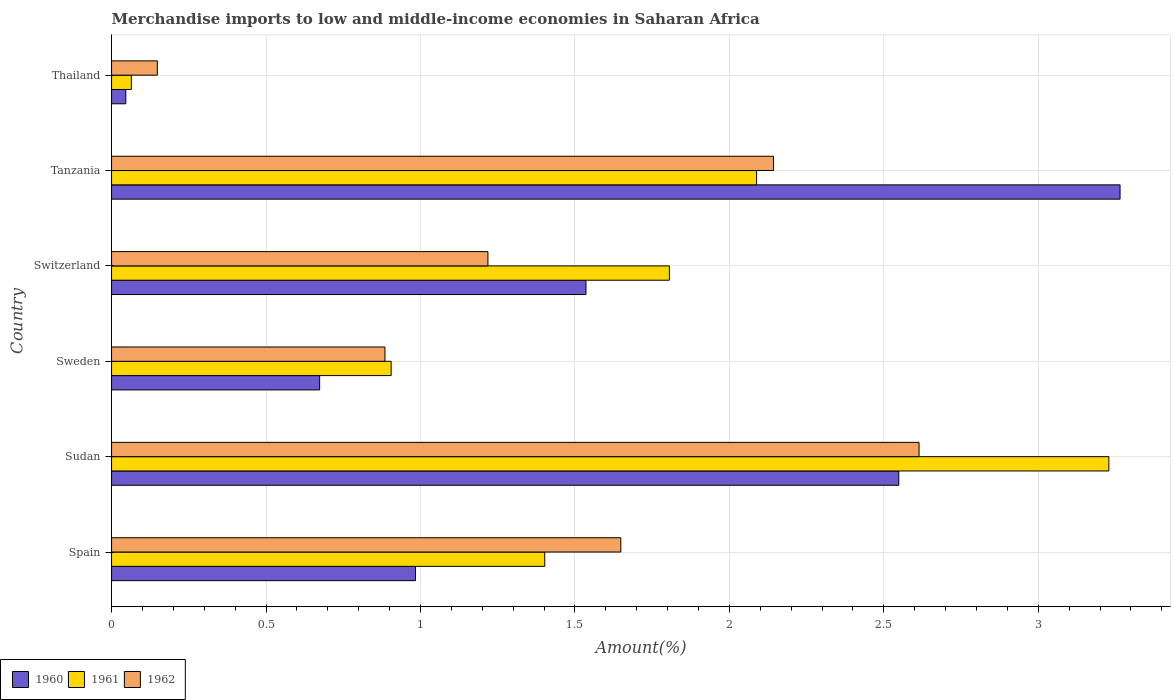How many different coloured bars are there?
Your answer should be compact. 3. How many groups of bars are there?
Your answer should be compact. 6. Are the number of bars per tick equal to the number of legend labels?
Your response must be concise. Yes. How many bars are there on the 1st tick from the top?
Provide a succinct answer. 3. How many bars are there on the 4th tick from the bottom?
Keep it short and to the point. 3. What is the label of the 1st group of bars from the top?
Give a very brief answer. Thailand. What is the percentage of amount earned from merchandise imports in 1960 in Spain?
Your response must be concise. 0.98. Across all countries, what is the maximum percentage of amount earned from merchandise imports in 1961?
Offer a terse response. 3.23. Across all countries, what is the minimum percentage of amount earned from merchandise imports in 1961?
Offer a terse response. 0.06. In which country was the percentage of amount earned from merchandise imports in 1962 maximum?
Provide a succinct answer. Sudan. In which country was the percentage of amount earned from merchandise imports in 1960 minimum?
Ensure brevity in your answer.  Thailand. What is the total percentage of amount earned from merchandise imports in 1961 in the graph?
Provide a succinct answer. 9.49. What is the difference between the percentage of amount earned from merchandise imports in 1960 in Sudan and that in Switzerland?
Your answer should be very brief. 1.01. What is the difference between the percentage of amount earned from merchandise imports in 1962 in Thailand and the percentage of amount earned from merchandise imports in 1960 in Sweden?
Offer a very short reply. -0.53. What is the average percentage of amount earned from merchandise imports in 1961 per country?
Your response must be concise. 1.58. What is the difference between the percentage of amount earned from merchandise imports in 1961 and percentage of amount earned from merchandise imports in 1962 in Tanzania?
Keep it short and to the point. -0.05. What is the ratio of the percentage of amount earned from merchandise imports in 1961 in Spain to that in Sudan?
Offer a terse response. 0.43. Is the percentage of amount earned from merchandise imports in 1960 in Sweden less than that in Thailand?
Make the answer very short. No. Is the difference between the percentage of amount earned from merchandise imports in 1961 in Sudan and Thailand greater than the difference between the percentage of amount earned from merchandise imports in 1962 in Sudan and Thailand?
Your response must be concise. Yes. What is the difference between the highest and the second highest percentage of amount earned from merchandise imports in 1961?
Keep it short and to the point. 1.14. What is the difference between the highest and the lowest percentage of amount earned from merchandise imports in 1962?
Give a very brief answer. 2.47. In how many countries, is the percentage of amount earned from merchandise imports in 1961 greater than the average percentage of amount earned from merchandise imports in 1961 taken over all countries?
Your answer should be very brief. 3. What does the 2nd bar from the top in Sweden represents?
Ensure brevity in your answer.  1961. What does the 3rd bar from the bottom in Spain represents?
Your response must be concise. 1962. Is it the case that in every country, the sum of the percentage of amount earned from merchandise imports in 1961 and percentage of amount earned from merchandise imports in 1960 is greater than the percentage of amount earned from merchandise imports in 1962?
Your response must be concise. No. Are the values on the major ticks of X-axis written in scientific E-notation?
Offer a very short reply. No. Does the graph contain any zero values?
Offer a very short reply. No. What is the title of the graph?
Your response must be concise. Merchandise imports to low and middle-income economies in Saharan Africa. Does "1973" appear as one of the legend labels in the graph?
Offer a very short reply. No. What is the label or title of the X-axis?
Provide a short and direct response. Amount(%). What is the label or title of the Y-axis?
Make the answer very short. Country. What is the Amount(%) of 1960 in Spain?
Your response must be concise. 0.98. What is the Amount(%) in 1961 in Spain?
Your answer should be compact. 1.4. What is the Amount(%) in 1962 in Spain?
Provide a succinct answer. 1.65. What is the Amount(%) of 1960 in Sudan?
Offer a terse response. 2.55. What is the Amount(%) in 1961 in Sudan?
Your answer should be compact. 3.23. What is the Amount(%) in 1962 in Sudan?
Your answer should be compact. 2.61. What is the Amount(%) of 1960 in Sweden?
Keep it short and to the point. 0.67. What is the Amount(%) in 1961 in Sweden?
Ensure brevity in your answer.  0.91. What is the Amount(%) of 1962 in Sweden?
Offer a terse response. 0.89. What is the Amount(%) of 1960 in Switzerland?
Make the answer very short. 1.54. What is the Amount(%) in 1961 in Switzerland?
Offer a terse response. 1.81. What is the Amount(%) of 1962 in Switzerland?
Offer a very short reply. 1.22. What is the Amount(%) in 1960 in Tanzania?
Keep it short and to the point. 3.26. What is the Amount(%) of 1961 in Tanzania?
Make the answer very short. 2.09. What is the Amount(%) in 1962 in Tanzania?
Offer a very short reply. 2.14. What is the Amount(%) of 1960 in Thailand?
Your answer should be very brief. 0.05. What is the Amount(%) in 1961 in Thailand?
Offer a terse response. 0.06. What is the Amount(%) in 1962 in Thailand?
Provide a short and direct response. 0.15. Across all countries, what is the maximum Amount(%) in 1960?
Offer a very short reply. 3.26. Across all countries, what is the maximum Amount(%) of 1961?
Give a very brief answer. 3.23. Across all countries, what is the maximum Amount(%) in 1962?
Give a very brief answer. 2.61. Across all countries, what is the minimum Amount(%) of 1960?
Your response must be concise. 0.05. Across all countries, what is the minimum Amount(%) of 1961?
Keep it short and to the point. 0.06. Across all countries, what is the minimum Amount(%) in 1962?
Give a very brief answer. 0.15. What is the total Amount(%) of 1960 in the graph?
Offer a terse response. 9.05. What is the total Amount(%) in 1961 in the graph?
Provide a short and direct response. 9.49. What is the total Amount(%) of 1962 in the graph?
Keep it short and to the point. 8.66. What is the difference between the Amount(%) in 1960 in Spain and that in Sudan?
Give a very brief answer. -1.56. What is the difference between the Amount(%) in 1961 in Spain and that in Sudan?
Give a very brief answer. -1.83. What is the difference between the Amount(%) of 1962 in Spain and that in Sudan?
Provide a succinct answer. -0.97. What is the difference between the Amount(%) in 1960 in Spain and that in Sweden?
Give a very brief answer. 0.31. What is the difference between the Amount(%) of 1961 in Spain and that in Sweden?
Make the answer very short. 0.5. What is the difference between the Amount(%) of 1962 in Spain and that in Sweden?
Your answer should be compact. 0.76. What is the difference between the Amount(%) of 1960 in Spain and that in Switzerland?
Your response must be concise. -0.55. What is the difference between the Amount(%) in 1961 in Spain and that in Switzerland?
Your answer should be very brief. -0.4. What is the difference between the Amount(%) of 1962 in Spain and that in Switzerland?
Provide a short and direct response. 0.43. What is the difference between the Amount(%) in 1960 in Spain and that in Tanzania?
Offer a terse response. -2.28. What is the difference between the Amount(%) of 1961 in Spain and that in Tanzania?
Ensure brevity in your answer.  -0.69. What is the difference between the Amount(%) in 1962 in Spain and that in Tanzania?
Your response must be concise. -0.49. What is the difference between the Amount(%) of 1960 in Spain and that in Thailand?
Make the answer very short. 0.94. What is the difference between the Amount(%) of 1961 in Spain and that in Thailand?
Make the answer very short. 1.34. What is the difference between the Amount(%) in 1962 in Spain and that in Thailand?
Make the answer very short. 1.5. What is the difference between the Amount(%) of 1960 in Sudan and that in Sweden?
Your response must be concise. 1.87. What is the difference between the Amount(%) in 1961 in Sudan and that in Sweden?
Offer a terse response. 2.32. What is the difference between the Amount(%) in 1962 in Sudan and that in Sweden?
Ensure brevity in your answer.  1.73. What is the difference between the Amount(%) of 1960 in Sudan and that in Switzerland?
Your answer should be compact. 1.01. What is the difference between the Amount(%) of 1961 in Sudan and that in Switzerland?
Ensure brevity in your answer.  1.42. What is the difference between the Amount(%) of 1962 in Sudan and that in Switzerland?
Provide a succinct answer. 1.4. What is the difference between the Amount(%) of 1960 in Sudan and that in Tanzania?
Make the answer very short. -0.72. What is the difference between the Amount(%) of 1961 in Sudan and that in Tanzania?
Offer a terse response. 1.14. What is the difference between the Amount(%) of 1962 in Sudan and that in Tanzania?
Your answer should be very brief. 0.47. What is the difference between the Amount(%) in 1960 in Sudan and that in Thailand?
Make the answer very short. 2.5. What is the difference between the Amount(%) in 1961 in Sudan and that in Thailand?
Keep it short and to the point. 3.16. What is the difference between the Amount(%) of 1962 in Sudan and that in Thailand?
Give a very brief answer. 2.47. What is the difference between the Amount(%) of 1960 in Sweden and that in Switzerland?
Offer a very short reply. -0.86. What is the difference between the Amount(%) in 1961 in Sweden and that in Switzerland?
Give a very brief answer. -0.9. What is the difference between the Amount(%) in 1962 in Sweden and that in Switzerland?
Provide a succinct answer. -0.33. What is the difference between the Amount(%) of 1960 in Sweden and that in Tanzania?
Make the answer very short. -2.59. What is the difference between the Amount(%) of 1961 in Sweden and that in Tanzania?
Offer a terse response. -1.18. What is the difference between the Amount(%) in 1962 in Sweden and that in Tanzania?
Keep it short and to the point. -1.26. What is the difference between the Amount(%) in 1960 in Sweden and that in Thailand?
Your answer should be very brief. 0.63. What is the difference between the Amount(%) in 1961 in Sweden and that in Thailand?
Offer a terse response. 0.84. What is the difference between the Amount(%) in 1962 in Sweden and that in Thailand?
Offer a very short reply. 0.74. What is the difference between the Amount(%) in 1960 in Switzerland and that in Tanzania?
Provide a short and direct response. -1.73. What is the difference between the Amount(%) in 1961 in Switzerland and that in Tanzania?
Your answer should be compact. -0.28. What is the difference between the Amount(%) in 1962 in Switzerland and that in Tanzania?
Make the answer very short. -0.92. What is the difference between the Amount(%) in 1960 in Switzerland and that in Thailand?
Give a very brief answer. 1.49. What is the difference between the Amount(%) of 1961 in Switzerland and that in Thailand?
Your answer should be very brief. 1.74. What is the difference between the Amount(%) of 1962 in Switzerland and that in Thailand?
Give a very brief answer. 1.07. What is the difference between the Amount(%) of 1960 in Tanzania and that in Thailand?
Ensure brevity in your answer.  3.22. What is the difference between the Amount(%) of 1961 in Tanzania and that in Thailand?
Make the answer very short. 2.02. What is the difference between the Amount(%) in 1962 in Tanzania and that in Thailand?
Provide a succinct answer. 1.99. What is the difference between the Amount(%) in 1960 in Spain and the Amount(%) in 1961 in Sudan?
Offer a very short reply. -2.24. What is the difference between the Amount(%) in 1960 in Spain and the Amount(%) in 1962 in Sudan?
Offer a terse response. -1.63. What is the difference between the Amount(%) in 1961 in Spain and the Amount(%) in 1962 in Sudan?
Your response must be concise. -1.21. What is the difference between the Amount(%) of 1960 in Spain and the Amount(%) of 1961 in Sweden?
Provide a succinct answer. 0.08. What is the difference between the Amount(%) in 1960 in Spain and the Amount(%) in 1962 in Sweden?
Your answer should be compact. 0.1. What is the difference between the Amount(%) in 1961 in Spain and the Amount(%) in 1962 in Sweden?
Offer a very short reply. 0.52. What is the difference between the Amount(%) in 1960 in Spain and the Amount(%) in 1961 in Switzerland?
Keep it short and to the point. -0.82. What is the difference between the Amount(%) in 1960 in Spain and the Amount(%) in 1962 in Switzerland?
Make the answer very short. -0.23. What is the difference between the Amount(%) of 1961 in Spain and the Amount(%) of 1962 in Switzerland?
Provide a short and direct response. 0.18. What is the difference between the Amount(%) in 1960 in Spain and the Amount(%) in 1961 in Tanzania?
Provide a succinct answer. -1.1. What is the difference between the Amount(%) in 1960 in Spain and the Amount(%) in 1962 in Tanzania?
Your response must be concise. -1.16. What is the difference between the Amount(%) of 1961 in Spain and the Amount(%) of 1962 in Tanzania?
Give a very brief answer. -0.74. What is the difference between the Amount(%) of 1960 in Spain and the Amount(%) of 1961 in Thailand?
Make the answer very short. 0.92. What is the difference between the Amount(%) in 1960 in Spain and the Amount(%) in 1962 in Thailand?
Your answer should be compact. 0.84. What is the difference between the Amount(%) in 1961 in Spain and the Amount(%) in 1962 in Thailand?
Ensure brevity in your answer.  1.25. What is the difference between the Amount(%) in 1960 in Sudan and the Amount(%) in 1961 in Sweden?
Keep it short and to the point. 1.64. What is the difference between the Amount(%) of 1960 in Sudan and the Amount(%) of 1962 in Sweden?
Offer a terse response. 1.66. What is the difference between the Amount(%) of 1961 in Sudan and the Amount(%) of 1962 in Sweden?
Your answer should be very brief. 2.34. What is the difference between the Amount(%) in 1960 in Sudan and the Amount(%) in 1961 in Switzerland?
Give a very brief answer. 0.74. What is the difference between the Amount(%) in 1960 in Sudan and the Amount(%) in 1962 in Switzerland?
Provide a short and direct response. 1.33. What is the difference between the Amount(%) of 1961 in Sudan and the Amount(%) of 1962 in Switzerland?
Your answer should be very brief. 2.01. What is the difference between the Amount(%) in 1960 in Sudan and the Amount(%) in 1961 in Tanzania?
Your response must be concise. 0.46. What is the difference between the Amount(%) in 1960 in Sudan and the Amount(%) in 1962 in Tanzania?
Ensure brevity in your answer.  0.41. What is the difference between the Amount(%) of 1961 in Sudan and the Amount(%) of 1962 in Tanzania?
Your response must be concise. 1.09. What is the difference between the Amount(%) of 1960 in Sudan and the Amount(%) of 1961 in Thailand?
Your answer should be compact. 2.48. What is the difference between the Amount(%) of 1960 in Sudan and the Amount(%) of 1962 in Thailand?
Offer a terse response. 2.4. What is the difference between the Amount(%) in 1961 in Sudan and the Amount(%) in 1962 in Thailand?
Ensure brevity in your answer.  3.08. What is the difference between the Amount(%) in 1960 in Sweden and the Amount(%) in 1961 in Switzerland?
Ensure brevity in your answer.  -1.13. What is the difference between the Amount(%) in 1960 in Sweden and the Amount(%) in 1962 in Switzerland?
Make the answer very short. -0.54. What is the difference between the Amount(%) in 1961 in Sweden and the Amount(%) in 1962 in Switzerland?
Make the answer very short. -0.31. What is the difference between the Amount(%) of 1960 in Sweden and the Amount(%) of 1961 in Tanzania?
Your answer should be compact. -1.41. What is the difference between the Amount(%) of 1960 in Sweden and the Amount(%) of 1962 in Tanzania?
Make the answer very short. -1.47. What is the difference between the Amount(%) in 1961 in Sweden and the Amount(%) in 1962 in Tanzania?
Provide a short and direct response. -1.24. What is the difference between the Amount(%) of 1960 in Sweden and the Amount(%) of 1961 in Thailand?
Offer a terse response. 0.61. What is the difference between the Amount(%) in 1960 in Sweden and the Amount(%) in 1962 in Thailand?
Provide a succinct answer. 0.53. What is the difference between the Amount(%) in 1961 in Sweden and the Amount(%) in 1962 in Thailand?
Ensure brevity in your answer.  0.76. What is the difference between the Amount(%) in 1960 in Switzerland and the Amount(%) in 1961 in Tanzania?
Your response must be concise. -0.55. What is the difference between the Amount(%) of 1960 in Switzerland and the Amount(%) of 1962 in Tanzania?
Your answer should be compact. -0.61. What is the difference between the Amount(%) in 1961 in Switzerland and the Amount(%) in 1962 in Tanzania?
Provide a succinct answer. -0.34. What is the difference between the Amount(%) of 1960 in Switzerland and the Amount(%) of 1961 in Thailand?
Ensure brevity in your answer.  1.47. What is the difference between the Amount(%) of 1960 in Switzerland and the Amount(%) of 1962 in Thailand?
Offer a terse response. 1.39. What is the difference between the Amount(%) of 1961 in Switzerland and the Amount(%) of 1962 in Thailand?
Offer a very short reply. 1.66. What is the difference between the Amount(%) of 1960 in Tanzania and the Amount(%) of 1961 in Thailand?
Provide a succinct answer. 3.2. What is the difference between the Amount(%) of 1960 in Tanzania and the Amount(%) of 1962 in Thailand?
Your answer should be very brief. 3.12. What is the difference between the Amount(%) of 1961 in Tanzania and the Amount(%) of 1962 in Thailand?
Offer a very short reply. 1.94. What is the average Amount(%) of 1960 per country?
Your answer should be compact. 1.51. What is the average Amount(%) of 1961 per country?
Keep it short and to the point. 1.58. What is the average Amount(%) of 1962 per country?
Your response must be concise. 1.44. What is the difference between the Amount(%) of 1960 and Amount(%) of 1961 in Spain?
Offer a very short reply. -0.42. What is the difference between the Amount(%) in 1960 and Amount(%) in 1962 in Spain?
Your answer should be compact. -0.66. What is the difference between the Amount(%) of 1961 and Amount(%) of 1962 in Spain?
Your answer should be compact. -0.25. What is the difference between the Amount(%) in 1960 and Amount(%) in 1961 in Sudan?
Provide a succinct answer. -0.68. What is the difference between the Amount(%) in 1960 and Amount(%) in 1962 in Sudan?
Provide a short and direct response. -0.07. What is the difference between the Amount(%) in 1961 and Amount(%) in 1962 in Sudan?
Your answer should be very brief. 0.61. What is the difference between the Amount(%) of 1960 and Amount(%) of 1961 in Sweden?
Provide a succinct answer. -0.23. What is the difference between the Amount(%) of 1960 and Amount(%) of 1962 in Sweden?
Give a very brief answer. -0.21. What is the difference between the Amount(%) in 1960 and Amount(%) in 1961 in Switzerland?
Ensure brevity in your answer.  -0.27. What is the difference between the Amount(%) of 1960 and Amount(%) of 1962 in Switzerland?
Offer a terse response. 0.32. What is the difference between the Amount(%) of 1961 and Amount(%) of 1962 in Switzerland?
Offer a very short reply. 0.59. What is the difference between the Amount(%) of 1960 and Amount(%) of 1961 in Tanzania?
Offer a terse response. 1.18. What is the difference between the Amount(%) in 1960 and Amount(%) in 1962 in Tanzania?
Your response must be concise. 1.12. What is the difference between the Amount(%) of 1961 and Amount(%) of 1962 in Tanzania?
Your answer should be compact. -0.05. What is the difference between the Amount(%) of 1960 and Amount(%) of 1961 in Thailand?
Your response must be concise. -0.02. What is the difference between the Amount(%) in 1960 and Amount(%) in 1962 in Thailand?
Keep it short and to the point. -0.1. What is the difference between the Amount(%) in 1961 and Amount(%) in 1962 in Thailand?
Make the answer very short. -0.08. What is the ratio of the Amount(%) in 1960 in Spain to that in Sudan?
Offer a terse response. 0.39. What is the ratio of the Amount(%) in 1961 in Spain to that in Sudan?
Ensure brevity in your answer.  0.43. What is the ratio of the Amount(%) of 1962 in Spain to that in Sudan?
Offer a very short reply. 0.63. What is the ratio of the Amount(%) of 1960 in Spain to that in Sweden?
Provide a succinct answer. 1.46. What is the ratio of the Amount(%) in 1961 in Spain to that in Sweden?
Your answer should be compact. 1.55. What is the ratio of the Amount(%) in 1962 in Spain to that in Sweden?
Offer a very short reply. 1.86. What is the ratio of the Amount(%) of 1960 in Spain to that in Switzerland?
Offer a very short reply. 0.64. What is the ratio of the Amount(%) of 1961 in Spain to that in Switzerland?
Offer a terse response. 0.78. What is the ratio of the Amount(%) in 1962 in Spain to that in Switzerland?
Your answer should be very brief. 1.35. What is the ratio of the Amount(%) of 1960 in Spain to that in Tanzania?
Provide a short and direct response. 0.3. What is the ratio of the Amount(%) of 1961 in Spain to that in Tanzania?
Provide a succinct answer. 0.67. What is the ratio of the Amount(%) of 1962 in Spain to that in Tanzania?
Keep it short and to the point. 0.77. What is the ratio of the Amount(%) of 1960 in Spain to that in Thailand?
Your response must be concise. 21.35. What is the ratio of the Amount(%) in 1961 in Spain to that in Thailand?
Offer a terse response. 21.89. What is the ratio of the Amount(%) in 1962 in Spain to that in Thailand?
Offer a terse response. 11.13. What is the ratio of the Amount(%) in 1960 in Sudan to that in Sweden?
Offer a terse response. 3.78. What is the ratio of the Amount(%) in 1961 in Sudan to that in Sweden?
Provide a short and direct response. 3.57. What is the ratio of the Amount(%) of 1962 in Sudan to that in Sweden?
Give a very brief answer. 2.95. What is the ratio of the Amount(%) of 1960 in Sudan to that in Switzerland?
Ensure brevity in your answer.  1.66. What is the ratio of the Amount(%) of 1961 in Sudan to that in Switzerland?
Your answer should be compact. 1.79. What is the ratio of the Amount(%) of 1962 in Sudan to that in Switzerland?
Offer a terse response. 2.15. What is the ratio of the Amount(%) in 1960 in Sudan to that in Tanzania?
Give a very brief answer. 0.78. What is the ratio of the Amount(%) of 1961 in Sudan to that in Tanzania?
Keep it short and to the point. 1.55. What is the ratio of the Amount(%) of 1962 in Sudan to that in Tanzania?
Provide a short and direct response. 1.22. What is the ratio of the Amount(%) of 1960 in Sudan to that in Thailand?
Your answer should be very brief. 55.3. What is the ratio of the Amount(%) in 1961 in Sudan to that in Thailand?
Your answer should be very brief. 50.41. What is the ratio of the Amount(%) of 1962 in Sudan to that in Thailand?
Keep it short and to the point. 17.65. What is the ratio of the Amount(%) of 1960 in Sweden to that in Switzerland?
Provide a short and direct response. 0.44. What is the ratio of the Amount(%) in 1961 in Sweden to that in Switzerland?
Ensure brevity in your answer.  0.5. What is the ratio of the Amount(%) of 1962 in Sweden to that in Switzerland?
Give a very brief answer. 0.73. What is the ratio of the Amount(%) of 1960 in Sweden to that in Tanzania?
Make the answer very short. 0.21. What is the ratio of the Amount(%) in 1961 in Sweden to that in Tanzania?
Give a very brief answer. 0.43. What is the ratio of the Amount(%) in 1962 in Sweden to that in Tanzania?
Your answer should be very brief. 0.41. What is the ratio of the Amount(%) in 1960 in Sweden to that in Thailand?
Offer a terse response. 14.62. What is the ratio of the Amount(%) in 1961 in Sweden to that in Thailand?
Provide a succinct answer. 14.13. What is the ratio of the Amount(%) of 1962 in Sweden to that in Thailand?
Provide a succinct answer. 5.98. What is the ratio of the Amount(%) of 1960 in Switzerland to that in Tanzania?
Your response must be concise. 0.47. What is the ratio of the Amount(%) in 1961 in Switzerland to that in Tanzania?
Your answer should be compact. 0.86. What is the ratio of the Amount(%) in 1962 in Switzerland to that in Tanzania?
Make the answer very short. 0.57. What is the ratio of the Amount(%) in 1960 in Switzerland to that in Thailand?
Offer a terse response. 33.33. What is the ratio of the Amount(%) of 1961 in Switzerland to that in Thailand?
Give a very brief answer. 28.2. What is the ratio of the Amount(%) in 1962 in Switzerland to that in Thailand?
Provide a succinct answer. 8.23. What is the ratio of the Amount(%) in 1960 in Tanzania to that in Thailand?
Offer a terse response. 70.85. What is the ratio of the Amount(%) of 1961 in Tanzania to that in Thailand?
Keep it short and to the point. 32.6. What is the ratio of the Amount(%) of 1962 in Tanzania to that in Thailand?
Offer a terse response. 14.47. What is the difference between the highest and the second highest Amount(%) in 1960?
Your answer should be compact. 0.72. What is the difference between the highest and the second highest Amount(%) of 1961?
Provide a succinct answer. 1.14. What is the difference between the highest and the second highest Amount(%) in 1962?
Provide a short and direct response. 0.47. What is the difference between the highest and the lowest Amount(%) in 1960?
Keep it short and to the point. 3.22. What is the difference between the highest and the lowest Amount(%) of 1961?
Give a very brief answer. 3.16. What is the difference between the highest and the lowest Amount(%) of 1962?
Offer a terse response. 2.47. 